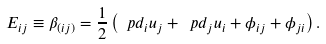<formula> <loc_0><loc_0><loc_500><loc_500>E _ { i j } \equiv \beta _ { ( i j ) } = \frac { 1 } { 2 } \left ( \ p d _ { i } u _ { j } + \ p d _ { j } u _ { i } + \phi _ { i j } + \phi _ { j i } \right ) .</formula> 